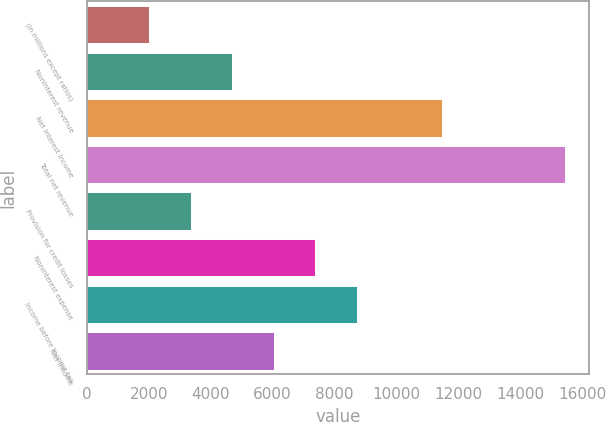Convert chart. <chart><loc_0><loc_0><loc_500><loc_500><bar_chart><fcel>(in millions except ratios)<fcel>Noninterest revenue<fcel>Net interest income<fcel>Total net revenue<fcel>Provision for credit losses<fcel>Noninterest expense<fcel>Income before income tax<fcel>Net income<nl><fcel>2013<fcel>4699<fcel>11466<fcel>15443<fcel>3356<fcel>7385<fcel>8728<fcel>6042<nl></chart> 